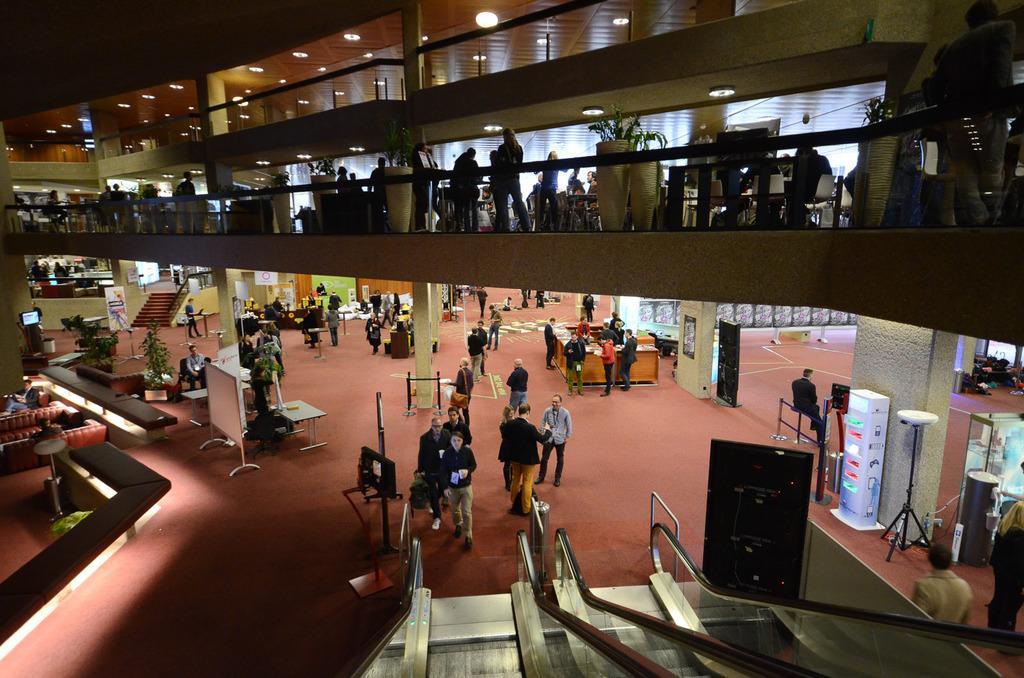Please provide a concise description of this image. In this image we can see the inside of a building. There are many people in the image. There are many chairs and tables in the image. We can see few couches at the left side of the image. There are many houseplants in the image. There are many objects in the image. There are many lights in the image. There are few staircases in the image. 